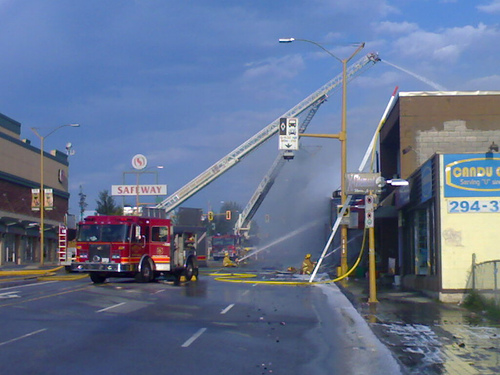<image>
Is the blue sign to the right of the white sign? Yes. From this viewpoint, the blue sign is positioned to the right side relative to the white sign. Is the firetruck next to the building? Yes. The firetruck is positioned adjacent to the building, located nearby in the same general area. 